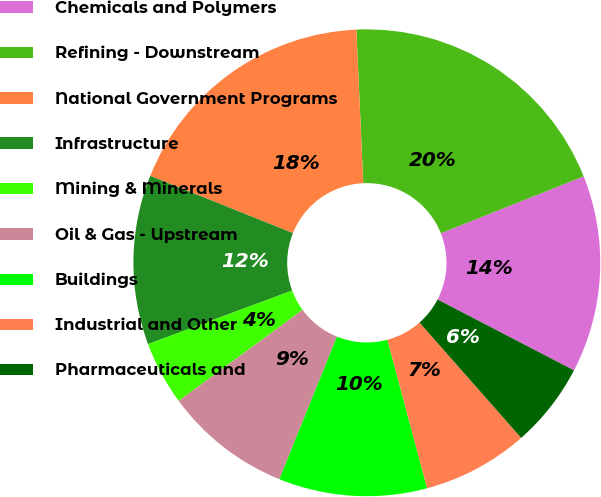<chart> <loc_0><loc_0><loc_500><loc_500><pie_chart><fcel>Chemicals and Polymers<fcel>Refining - Downstream<fcel>National Government Programs<fcel>Infrastructure<fcel>Mining & Minerals<fcel>Oil & Gas - Upstream<fcel>Buildings<fcel>Industrial and Other<fcel>Pharmaceuticals and<nl><fcel>13.66%<fcel>19.68%<fcel>18.21%<fcel>11.74%<fcel>4.41%<fcel>8.81%<fcel>10.27%<fcel>7.34%<fcel>5.88%<nl></chart> 